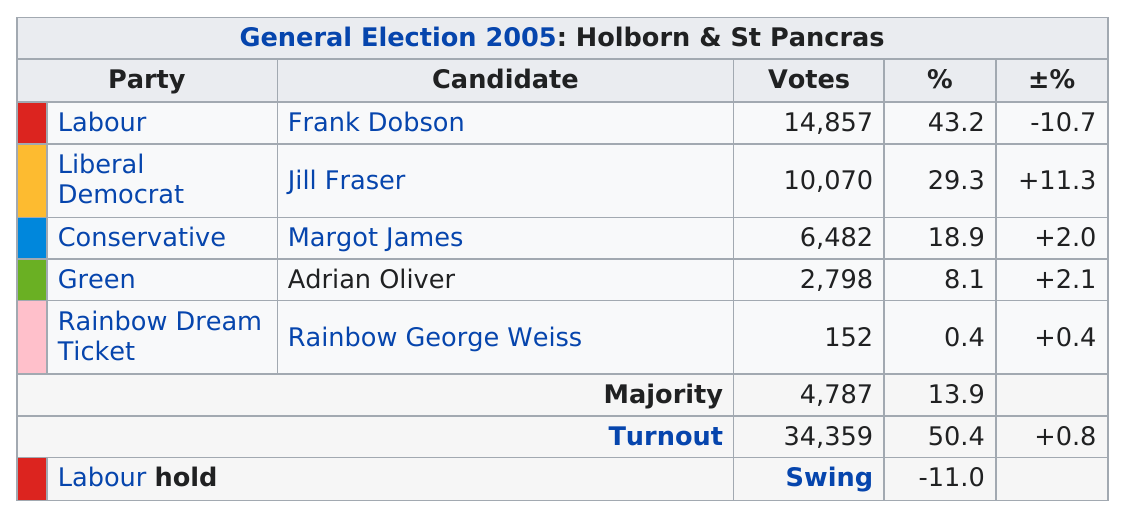Give some essential details in this illustration. According to the results, both the Conservative Party and the Rainbow Dream Ticket Party received a total of 6,634 votes. 